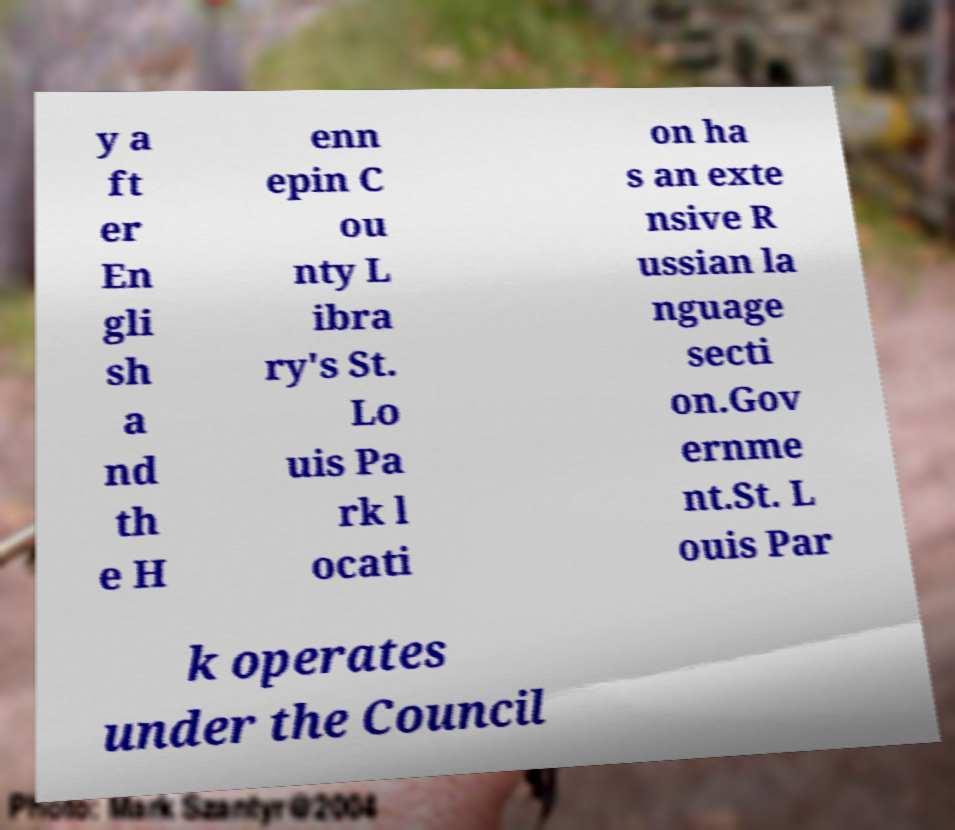Can you read and provide the text displayed in the image?This photo seems to have some interesting text. Can you extract and type it out for me? y a ft er En gli sh a nd th e H enn epin C ou nty L ibra ry's St. Lo uis Pa rk l ocati on ha s an exte nsive R ussian la nguage secti on.Gov ernme nt.St. L ouis Par k operates under the Council 